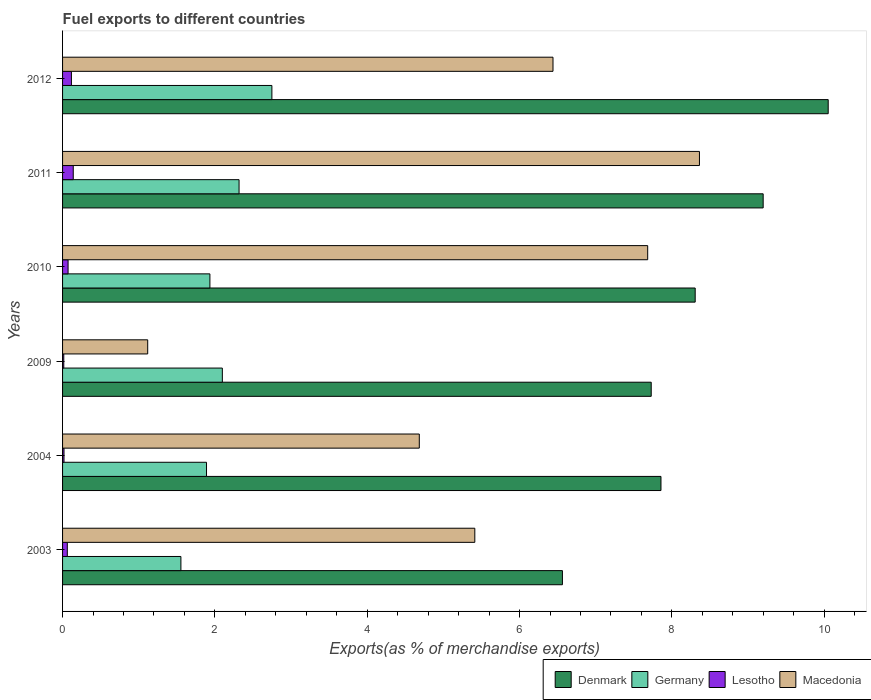Are the number of bars on each tick of the Y-axis equal?
Keep it short and to the point. Yes. How many bars are there on the 5th tick from the bottom?
Your answer should be compact. 4. What is the label of the 4th group of bars from the top?
Make the answer very short. 2009. In how many cases, is the number of bars for a given year not equal to the number of legend labels?
Provide a short and direct response. 0. What is the percentage of exports to different countries in Lesotho in 2009?
Your answer should be very brief. 0.02. Across all years, what is the maximum percentage of exports to different countries in Germany?
Your response must be concise. 2.75. Across all years, what is the minimum percentage of exports to different countries in Germany?
Your answer should be compact. 1.55. In which year was the percentage of exports to different countries in Denmark minimum?
Keep it short and to the point. 2003. What is the total percentage of exports to different countries in Denmark in the graph?
Provide a short and direct response. 49.7. What is the difference between the percentage of exports to different countries in Germany in 2003 and that in 2011?
Ensure brevity in your answer.  -0.76. What is the difference between the percentage of exports to different countries in Lesotho in 2009 and the percentage of exports to different countries in Denmark in 2012?
Offer a very short reply. -10.04. What is the average percentage of exports to different countries in Macedonia per year?
Offer a terse response. 5.62. In the year 2011, what is the difference between the percentage of exports to different countries in Denmark and percentage of exports to different countries in Germany?
Provide a succinct answer. 6.88. In how many years, is the percentage of exports to different countries in Macedonia greater than 7.6 %?
Provide a succinct answer. 2. What is the ratio of the percentage of exports to different countries in Germany in 2010 to that in 2012?
Make the answer very short. 0.7. Is the difference between the percentage of exports to different countries in Denmark in 2003 and 2004 greater than the difference between the percentage of exports to different countries in Germany in 2003 and 2004?
Make the answer very short. No. What is the difference between the highest and the second highest percentage of exports to different countries in Germany?
Ensure brevity in your answer.  0.43. What is the difference between the highest and the lowest percentage of exports to different countries in Lesotho?
Provide a short and direct response. 0.12. In how many years, is the percentage of exports to different countries in Germany greater than the average percentage of exports to different countries in Germany taken over all years?
Make the answer very short. 3. Is it the case that in every year, the sum of the percentage of exports to different countries in Denmark and percentage of exports to different countries in Lesotho is greater than the sum of percentage of exports to different countries in Macedonia and percentage of exports to different countries in Germany?
Offer a very short reply. Yes. What does the 2nd bar from the top in 2009 represents?
Give a very brief answer. Lesotho. What does the 4th bar from the bottom in 2010 represents?
Your answer should be very brief. Macedonia. How many bars are there?
Your answer should be compact. 24. Are all the bars in the graph horizontal?
Keep it short and to the point. Yes. How many years are there in the graph?
Your answer should be very brief. 6. Are the values on the major ticks of X-axis written in scientific E-notation?
Ensure brevity in your answer.  No. Where does the legend appear in the graph?
Offer a terse response. Bottom right. How many legend labels are there?
Provide a short and direct response. 4. What is the title of the graph?
Offer a very short reply. Fuel exports to different countries. What is the label or title of the X-axis?
Ensure brevity in your answer.  Exports(as % of merchandise exports). What is the label or title of the Y-axis?
Offer a terse response. Years. What is the Exports(as % of merchandise exports) in Denmark in 2003?
Give a very brief answer. 6.56. What is the Exports(as % of merchandise exports) of Germany in 2003?
Your answer should be compact. 1.55. What is the Exports(as % of merchandise exports) of Lesotho in 2003?
Offer a terse response. 0.06. What is the Exports(as % of merchandise exports) in Macedonia in 2003?
Ensure brevity in your answer.  5.41. What is the Exports(as % of merchandise exports) of Denmark in 2004?
Make the answer very short. 7.86. What is the Exports(as % of merchandise exports) of Germany in 2004?
Your answer should be compact. 1.89. What is the Exports(as % of merchandise exports) in Lesotho in 2004?
Make the answer very short. 0.02. What is the Exports(as % of merchandise exports) of Macedonia in 2004?
Make the answer very short. 4.68. What is the Exports(as % of merchandise exports) in Denmark in 2009?
Your answer should be compact. 7.73. What is the Exports(as % of merchandise exports) in Germany in 2009?
Keep it short and to the point. 2.1. What is the Exports(as % of merchandise exports) of Lesotho in 2009?
Offer a very short reply. 0.02. What is the Exports(as % of merchandise exports) of Macedonia in 2009?
Your response must be concise. 1.12. What is the Exports(as % of merchandise exports) of Denmark in 2010?
Your response must be concise. 8.31. What is the Exports(as % of merchandise exports) in Germany in 2010?
Offer a terse response. 1.93. What is the Exports(as % of merchandise exports) of Lesotho in 2010?
Make the answer very short. 0.07. What is the Exports(as % of merchandise exports) in Macedonia in 2010?
Your response must be concise. 7.68. What is the Exports(as % of merchandise exports) of Denmark in 2011?
Ensure brevity in your answer.  9.2. What is the Exports(as % of merchandise exports) in Germany in 2011?
Offer a very short reply. 2.32. What is the Exports(as % of merchandise exports) of Lesotho in 2011?
Offer a very short reply. 0.14. What is the Exports(as % of merchandise exports) in Macedonia in 2011?
Your response must be concise. 8.36. What is the Exports(as % of merchandise exports) of Denmark in 2012?
Keep it short and to the point. 10.05. What is the Exports(as % of merchandise exports) of Germany in 2012?
Ensure brevity in your answer.  2.75. What is the Exports(as % of merchandise exports) of Lesotho in 2012?
Give a very brief answer. 0.12. What is the Exports(as % of merchandise exports) of Macedonia in 2012?
Offer a very short reply. 6.44. Across all years, what is the maximum Exports(as % of merchandise exports) in Denmark?
Provide a succinct answer. 10.05. Across all years, what is the maximum Exports(as % of merchandise exports) of Germany?
Provide a succinct answer. 2.75. Across all years, what is the maximum Exports(as % of merchandise exports) in Lesotho?
Offer a terse response. 0.14. Across all years, what is the maximum Exports(as % of merchandise exports) in Macedonia?
Give a very brief answer. 8.36. Across all years, what is the minimum Exports(as % of merchandise exports) in Denmark?
Make the answer very short. 6.56. Across all years, what is the minimum Exports(as % of merchandise exports) in Germany?
Your response must be concise. 1.55. Across all years, what is the minimum Exports(as % of merchandise exports) in Lesotho?
Your response must be concise. 0.02. Across all years, what is the minimum Exports(as % of merchandise exports) of Macedonia?
Provide a short and direct response. 1.12. What is the total Exports(as % of merchandise exports) in Denmark in the graph?
Your response must be concise. 49.7. What is the total Exports(as % of merchandise exports) of Germany in the graph?
Your response must be concise. 12.54. What is the total Exports(as % of merchandise exports) of Lesotho in the graph?
Ensure brevity in your answer.  0.43. What is the total Exports(as % of merchandise exports) in Macedonia in the graph?
Offer a very short reply. 33.7. What is the difference between the Exports(as % of merchandise exports) of Denmark in 2003 and that in 2004?
Ensure brevity in your answer.  -1.29. What is the difference between the Exports(as % of merchandise exports) in Germany in 2003 and that in 2004?
Offer a very short reply. -0.34. What is the difference between the Exports(as % of merchandise exports) of Lesotho in 2003 and that in 2004?
Your answer should be very brief. 0.04. What is the difference between the Exports(as % of merchandise exports) in Macedonia in 2003 and that in 2004?
Offer a terse response. 0.73. What is the difference between the Exports(as % of merchandise exports) in Denmark in 2003 and that in 2009?
Provide a succinct answer. -1.17. What is the difference between the Exports(as % of merchandise exports) in Germany in 2003 and that in 2009?
Ensure brevity in your answer.  -0.54. What is the difference between the Exports(as % of merchandise exports) in Lesotho in 2003 and that in 2009?
Keep it short and to the point. 0.05. What is the difference between the Exports(as % of merchandise exports) in Macedonia in 2003 and that in 2009?
Offer a terse response. 4.29. What is the difference between the Exports(as % of merchandise exports) in Denmark in 2003 and that in 2010?
Your answer should be very brief. -1.74. What is the difference between the Exports(as % of merchandise exports) in Germany in 2003 and that in 2010?
Make the answer very short. -0.38. What is the difference between the Exports(as % of merchandise exports) of Lesotho in 2003 and that in 2010?
Provide a short and direct response. -0.01. What is the difference between the Exports(as % of merchandise exports) in Macedonia in 2003 and that in 2010?
Provide a succinct answer. -2.27. What is the difference between the Exports(as % of merchandise exports) in Denmark in 2003 and that in 2011?
Your response must be concise. -2.64. What is the difference between the Exports(as % of merchandise exports) of Germany in 2003 and that in 2011?
Keep it short and to the point. -0.76. What is the difference between the Exports(as % of merchandise exports) of Lesotho in 2003 and that in 2011?
Provide a succinct answer. -0.08. What is the difference between the Exports(as % of merchandise exports) of Macedonia in 2003 and that in 2011?
Make the answer very short. -2.95. What is the difference between the Exports(as % of merchandise exports) of Denmark in 2003 and that in 2012?
Offer a terse response. -3.49. What is the difference between the Exports(as % of merchandise exports) in Germany in 2003 and that in 2012?
Your response must be concise. -1.19. What is the difference between the Exports(as % of merchandise exports) of Lesotho in 2003 and that in 2012?
Provide a short and direct response. -0.05. What is the difference between the Exports(as % of merchandise exports) in Macedonia in 2003 and that in 2012?
Make the answer very short. -1.03. What is the difference between the Exports(as % of merchandise exports) in Denmark in 2004 and that in 2009?
Make the answer very short. 0.13. What is the difference between the Exports(as % of merchandise exports) in Germany in 2004 and that in 2009?
Your answer should be compact. -0.21. What is the difference between the Exports(as % of merchandise exports) in Lesotho in 2004 and that in 2009?
Your answer should be compact. 0. What is the difference between the Exports(as % of merchandise exports) in Macedonia in 2004 and that in 2009?
Keep it short and to the point. 3.57. What is the difference between the Exports(as % of merchandise exports) in Denmark in 2004 and that in 2010?
Keep it short and to the point. -0.45. What is the difference between the Exports(as % of merchandise exports) in Germany in 2004 and that in 2010?
Offer a terse response. -0.04. What is the difference between the Exports(as % of merchandise exports) in Lesotho in 2004 and that in 2010?
Your answer should be very brief. -0.05. What is the difference between the Exports(as % of merchandise exports) of Macedonia in 2004 and that in 2010?
Provide a short and direct response. -3. What is the difference between the Exports(as % of merchandise exports) of Denmark in 2004 and that in 2011?
Provide a succinct answer. -1.34. What is the difference between the Exports(as % of merchandise exports) in Germany in 2004 and that in 2011?
Provide a short and direct response. -0.43. What is the difference between the Exports(as % of merchandise exports) in Lesotho in 2004 and that in 2011?
Make the answer very short. -0.12. What is the difference between the Exports(as % of merchandise exports) of Macedonia in 2004 and that in 2011?
Make the answer very short. -3.68. What is the difference between the Exports(as % of merchandise exports) of Denmark in 2004 and that in 2012?
Offer a terse response. -2.2. What is the difference between the Exports(as % of merchandise exports) of Germany in 2004 and that in 2012?
Your answer should be very brief. -0.86. What is the difference between the Exports(as % of merchandise exports) in Lesotho in 2004 and that in 2012?
Your answer should be very brief. -0.1. What is the difference between the Exports(as % of merchandise exports) of Macedonia in 2004 and that in 2012?
Your answer should be compact. -1.76. What is the difference between the Exports(as % of merchandise exports) in Denmark in 2009 and that in 2010?
Offer a very short reply. -0.58. What is the difference between the Exports(as % of merchandise exports) of Germany in 2009 and that in 2010?
Keep it short and to the point. 0.16. What is the difference between the Exports(as % of merchandise exports) of Lesotho in 2009 and that in 2010?
Ensure brevity in your answer.  -0.06. What is the difference between the Exports(as % of merchandise exports) in Macedonia in 2009 and that in 2010?
Offer a very short reply. -6.56. What is the difference between the Exports(as % of merchandise exports) in Denmark in 2009 and that in 2011?
Your answer should be compact. -1.47. What is the difference between the Exports(as % of merchandise exports) of Germany in 2009 and that in 2011?
Offer a very short reply. -0.22. What is the difference between the Exports(as % of merchandise exports) in Lesotho in 2009 and that in 2011?
Your response must be concise. -0.12. What is the difference between the Exports(as % of merchandise exports) of Macedonia in 2009 and that in 2011?
Provide a short and direct response. -7.24. What is the difference between the Exports(as % of merchandise exports) in Denmark in 2009 and that in 2012?
Ensure brevity in your answer.  -2.32. What is the difference between the Exports(as % of merchandise exports) of Germany in 2009 and that in 2012?
Give a very brief answer. -0.65. What is the difference between the Exports(as % of merchandise exports) in Lesotho in 2009 and that in 2012?
Keep it short and to the point. -0.1. What is the difference between the Exports(as % of merchandise exports) of Macedonia in 2009 and that in 2012?
Ensure brevity in your answer.  -5.32. What is the difference between the Exports(as % of merchandise exports) in Denmark in 2010 and that in 2011?
Keep it short and to the point. -0.89. What is the difference between the Exports(as % of merchandise exports) in Germany in 2010 and that in 2011?
Provide a short and direct response. -0.38. What is the difference between the Exports(as % of merchandise exports) in Lesotho in 2010 and that in 2011?
Ensure brevity in your answer.  -0.07. What is the difference between the Exports(as % of merchandise exports) of Macedonia in 2010 and that in 2011?
Make the answer very short. -0.68. What is the difference between the Exports(as % of merchandise exports) in Denmark in 2010 and that in 2012?
Offer a very short reply. -1.75. What is the difference between the Exports(as % of merchandise exports) in Germany in 2010 and that in 2012?
Your response must be concise. -0.81. What is the difference between the Exports(as % of merchandise exports) of Lesotho in 2010 and that in 2012?
Your answer should be very brief. -0.04. What is the difference between the Exports(as % of merchandise exports) of Macedonia in 2010 and that in 2012?
Provide a succinct answer. 1.24. What is the difference between the Exports(as % of merchandise exports) in Denmark in 2011 and that in 2012?
Offer a terse response. -0.85. What is the difference between the Exports(as % of merchandise exports) of Germany in 2011 and that in 2012?
Keep it short and to the point. -0.43. What is the difference between the Exports(as % of merchandise exports) of Lesotho in 2011 and that in 2012?
Ensure brevity in your answer.  0.02. What is the difference between the Exports(as % of merchandise exports) of Macedonia in 2011 and that in 2012?
Keep it short and to the point. 1.92. What is the difference between the Exports(as % of merchandise exports) in Denmark in 2003 and the Exports(as % of merchandise exports) in Germany in 2004?
Provide a short and direct response. 4.67. What is the difference between the Exports(as % of merchandise exports) in Denmark in 2003 and the Exports(as % of merchandise exports) in Lesotho in 2004?
Give a very brief answer. 6.54. What is the difference between the Exports(as % of merchandise exports) in Denmark in 2003 and the Exports(as % of merchandise exports) in Macedonia in 2004?
Provide a short and direct response. 1.88. What is the difference between the Exports(as % of merchandise exports) of Germany in 2003 and the Exports(as % of merchandise exports) of Lesotho in 2004?
Keep it short and to the point. 1.53. What is the difference between the Exports(as % of merchandise exports) in Germany in 2003 and the Exports(as % of merchandise exports) in Macedonia in 2004?
Your response must be concise. -3.13. What is the difference between the Exports(as % of merchandise exports) in Lesotho in 2003 and the Exports(as % of merchandise exports) in Macedonia in 2004?
Keep it short and to the point. -4.62. What is the difference between the Exports(as % of merchandise exports) of Denmark in 2003 and the Exports(as % of merchandise exports) of Germany in 2009?
Your answer should be very brief. 4.46. What is the difference between the Exports(as % of merchandise exports) in Denmark in 2003 and the Exports(as % of merchandise exports) in Lesotho in 2009?
Your answer should be compact. 6.55. What is the difference between the Exports(as % of merchandise exports) in Denmark in 2003 and the Exports(as % of merchandise exports) in Macedonia in 2009?
Make the answer very short. 5.44. What is the difference between the Exports(as % of merchandise exports) in Germany in 2003 and the Exports(as % of merchandise exports) in Lesotho in 2009?
Offer a very short reply. 1.54. What is the difference between the Exports(as % of merchandise exports) of Germany in 2003 and the Exports(as % of merchandise exports) of Macedonia in 2009?
Your answer should be very brief. 0.44. What is the difference between the Exports(as % of merchandise exports) in Lesotho in 2003 and the Exports(as % of merchandise exports) in Macedonia in 2009?
Your response must be concise. -1.06. What is the difference between the Exports(as % of merchandise exports) in Denmark in 2003 and the Exports(as % of merchandise exports) in Germany in 2010?
Your response must be concise. 4.63. What is the difference between the Exports(as % of merchandise exports) of Denmark in 2003 and the Exports(as % of merchandise exports) of Lesotho in 2010?
Your answer should be very brief. 6.49. What is the difference between the Exports(as % of merchandise exports) of Denmark in 2003 and the Exports(as % of merchandise exports) of Macedonia in 2010?
Your answer should be compact. -1.12. What is the difference between the Exports(as % of merchandise exports) in Germany in 2003 and the Exports(as % of merchandise exports) in Lesotho in 2010?
Ensure brevity in your answer.  1.48. What is the difference between the Exports(as % of merchandise exports) in Germany in 2003 and the Exports(as % of merchandise exports) in Macedonia in 2010?
Your response must be concise. -6.13. What is the difference between the Exports(as % of merchandise exports) of Lesotho in 2003 and the Exports(as % of merchandise exports) of Macedonia in 2010?
Provide a short and direct response. -7.62. What is the difference between the Exports(as % of merchandise exports) in Denmark in 2003 and the Exports(as % of merchandise exports) in Germany in 2011?
Offer a very short reply. 4.25. What is the difference between the Exports(as % of merchandise exports) of Denmark in 2003 and the Exports(as % of merchandise exports) of Lesotho in 2011?
Your answer should be very brief. 6.42. What is the difference between the Exports(as % of merchandise exports) in Denmark in 2003 and the Exports(as % of merchandise exports) in Macedonia in 2011?
Ensure brevity in your answer.  -1.8. What is the difference between the Exports(as % of merchandise exports) in Germany in 2003 and the Exports(as % of merchandise exports) in Lesotho in 2011?
Offer a very short reply. 1.41. What is the difference between the Exports(as % of merchandise exports) of Germany in 2003 and the Exports(as % of merchandise exports) of Macedonia in 2011?
Your answer should be very brief. -6.81. What is the difference between the Exports(as % of merchandise exports) in Lesotho in 2003 and the Exports(as % of merchandise exports) in Macedonia in 2011?
Make the answer very short. -8.3. What is the difference between the Exports(as % of merchandise exports) of Denmark in 2003 and the Exports(as % of merchandise exports) of Germany in 2012?
Your response must be concise. 3.81. What is the difference between the Exports(as % of merchandise exports) of Denmark in 2003 and the Exports(as % of merchandise exports) of Lesotho in 2012?
Your answer should be very brief. 6.45. What is the difference between the Exports(as % of merchandise exports) of Denmark in 2003 and the Exports(as % of merchandise exports) of Macedonia in 2012?
Your answer should be very brief. 0.12. What is the difference between the Exports(as % of merchandise exports) in Germany in 2003 and the Exports(as % of merchandise exports) in Lesotho in 2012?
Offer a very short reply. 1.44. What is the difference between the Exports(as % of merchandise exports) in Germany in 2003 and the Exports(as % of merchandise exports) in Macedonia in 2012?
Provide a succinct answer. -4.89. What is the difference between the Exports(as % of merchandise exports) in Lesotho in 2003 and the Exports(as % of merchandise exports) in Macedonia in 2012?
Give a very brief answer. -6.38. What is the difference between the Exports(as % of merchandise exports) of Denmark in 2004 and the Exports(as % of merchandise exports) of Germany in 2009?
Keep it short and to the point. 5.76. What is the difference between the Exports(as % of merchandise exports) of Denmark in 2004 and the Exports(as % of merchandise exports) of Lesotho in 2009?
Give a very brief answer. 7.84. What is the difference between the Exports(as % of merchandise exports) of Denmark in 2004 and the Exports(as % of merchandise exports) of Macedonia in 2009?
Your answer should be very brief. 6.74. What is the difference between the Exports(as % of merchandise exports) in Germany in 2004 and the Exports(as % of merchandise exports) in Lesotho in 2009?
Offer a very short reply. 1.87. What is the difference between the Exports(as % of merchandise exports) of Germany in 2004 and the Exports(as % of merchandise exports) of Macedonia in 2009?
Your answer should be compact. 0.77. What is the difference between the Exports(as % of merchandise exports) in Lesotho in 2004 and the Exports(as % of merchandise exports) in Macedonia in 2009?
Offer a very short reply. -1.1. What is the difference between the Exports(as % of merchandise exports) in Denmark in 2004 and the Exports(as % of merchandise exports) in Germany in 2010?
Provide a succinct answer. 5.92. What is the difference between the Exports(as % of merchandise exports) of Denmark in 2004 and the Exports(as % of merchandise exports) of Lesotho in 2010?
Your answer should be compact. 7.78. What is the difference between the Exports(as % of merchandise exports) of Denmark in 2004 and the Exports(as % of merchandise exports) of Macedonia in 2010?
Ensure brevity in your answer.  0.17. What is the difference between the Exports(as % of merchandise exports) in Germany in 2004 and the Exports(as % of merchandise exports) in Lesotho in 2010?
Offer a terse response. 1.82. What is the difference between the Exports(as % of merchandise exports) of Germany in 2004 and the Exports(as % of merchandise exports) of Macedonia in 2010?
Your answer should be very brief. -5.79. What is the difference between the Exports(as % of merchandise exports) in Lesotho in 2004 and the Exports(as % of merchandise exports) in Macedonia in 2010?
Your answer should be very brief. -7.66. What is the difference between the Exports(as % of merchandise exports) in Denmark in 2004 and the Exports(as % of merchandise exports) in Germany in 2011?
Make the answer very short. 5.54. What is the difference between the Exports(as % of merchandise exports) of Denmark in 2004 and the Exports(as % of merchandise exports) of Lesotho in 2011?
Offer a very short reply. 7.72. What is the difference between the Exports(as % of merchandise exports) in Denmark in 2004 and the Exports(as % of merchandise exports) in Macedonia in 2011?
Keep it short and to the point. -0.51. What is the difference between the Exports(as % of merchandise exports) in Germany in 2004 and the Exports(as % of merchandise exports) in Lesotho in 2011?
Give a very brief answer. 1.75. What is the difference between the Exports(as % of merchandise exports) of Germany in 2004 and the Exports(as % of merchandise exports) of Macedonia in 2011?
Make the answer very short. -6.47. What is the difference between the Exports(as % of merchandise exports) in Lesotho in 2004 and the Exports(as % of merchandise exports) in Macedonia in 2011?
Ensure brevity in your answer.  -8.34. What is the difference between the Exports(as % of merchandise exports) in Denmark in 2004 and the Exports(as % of merchandise exports) in Germany in 2012?
Your response must be concise. 5.11. What is the difference between the Exports(as % of merchandise exports) in Denmark in 2004 and the Exports(as % of merchandise exports) in Lesotho in 2012?
Provide a succinct answer. 7.74. What is the difference between the Exports(as % of merchandise exports) of Denmark in 2004 and the Exports(as % of merchandise exports) of Macedonia in 2012?
Make the answer very short. 1.42. What is the difference between the Exports(as % of merchandise exports) of Germany in 2004 and the Exports(as % of merchandise exports) of Lesotho in 2012?
Keep it short and to the point. 1.77. What is the difference between the Exports(as % of merchandise exports) in Germany in 2004 and the Exports(as % of merchandise exports) in Macedonia in 2012?
Provide a short and direct response. -4.55. What is the difference between the Exports(as % of merchandise exports) of Lesotho in 2004 and the Exports(as % of merchandise exports) of Macedonia in 2012?
Ensure brevity in your answer.  -6.42. What is the difference between the Exports(as % of merchandise exports) in Denmark in 2009 and the Exports(as % of merchandise exports) in Germany in 2010?
Offer a terse response. 5.79. What is the difference between the Exports(as % of merchandise exports) in Denmark in 2009 and the Exports(as % of merchandise exports) in Lesotho in 2010?
Your response must be concise. 7.66. What is the difference between the Exports(as % of merchandise exports) of Denmark in 2009 and the Exports(as % of merchandise exports) of Macedonia in 2010?
Your answer should be compact. 0.05. What is the difference between the Exports(as % of merchandise exports) of Germany in 2009 and the Exports(as % of merchandise exports) of Lesotho in 2010?
Your response must be concise. 2.03. What is the difference between the Exports(as % of merchandise exports) of Germany in 2009 and the Exports(as % of merchandise exports) of Macedonia in 2010?
Offer a very short reply. -5.58. What is the difference between the Exports(as % of merchandise exports) of Lesotho in 2009 and the Exports(as % of merchandise exports) of Macedonia in 2010?
Your answer should be compact. -7.67. What is the difference between the Exports(as % of merchandise exports) in Denmark in 2009 and the Exports(as % of merchandise exports) in Germany in 2011?
Your answer should be compact. 5.41. What is the difference between the Exports(as % of merchandise exports) of Denmark in 2009 and the Exports(as % of merchandise exports) of Lesotho in 2011?
Your answer should be compact. 7.59. What is the difference between the Exports(as % of merchandise exports) in Denmark in 2009 and the Exports(as % of merchandise exports) in Macedonia in 2011?
Your answer should be very brief. -0.63. What is the difference between the Exports(as % of merchandise exports) of Germany in 2009 and the Exports(as % of merchandise exports) of Lesotho in 2011?
Keep it short and to the point. 1.96. What is the difference between the Exports(as % of merchandise exports) in Germany in 2009 and the Exports(as % of merchandise exports) in Macedonia in 2011?
Make the answer very short. -6.26. What is the difference between the Exports(as % of merchandise exports) in Lesotho in 2009 and the Exports(as % of merchandise exports) in Macedonia in 2011?
Offer a terse response. -8.35. What is the difference between the Exports(as % of merchandise exports) of Denmark in 2009 and the Exports(as % of merchandise exports) of Germany in 2012?
Your answer should be very brief. 4.98. What is the difference between the Exports(as % of merchandise exports) in Denmark in 2009 and the Exports(as % of merchandise exports) in Lesotho in 2012?
Provide a short and direct response. 7.61. What is the difference between the Exports(as % of merchandise exports) in Denmark in 2009 and the Exports(as % of merchandise exports) in Macedonia in 2012?
Your answer should be very brief. 1.29. What is the difference between the Exports(as % of merchandise exports) of Germany in 2009 and the Exports(as % of merchandise exports) of Lesotho in 2012?
Offer a very short reply. 1.98. What is the difference between the Exports(as % of merchandise exports) of Germany in 2009 and the Exports(as % of merchandise exports) of Macedonia in 2012?
Offer a terse response. -4.34. What is the difference between the Exports(as % of merchandise exports) in Lesotho in 2009 and the Exports(as % of merchandise exports) in Macedonia in 2012?
Offer a terse response. -6.42. What is the difference between the Exports(as % of merchandise exports) of Denmark in 2010 and the Exports(as % of merchandise exports) of Germany in 2011?
Your answer should be very brief. 5.99. What is the difference between the Exports(as % of merchandise exports) of Denmark in 2010 and the Exports(as % of merchandise exports) of Lesotho in 2011?
Offer a very short reply. 8.17. What is the difference between the Exports(as % of merchandise exports) of Denmark in 2010 and the Exports(as % of merchandise exports) of Macedonia in 2011?
Your answer should be very brief. -0.06. What is the difference between the Exports(as % of merchandise exports) in Germany in 2010 and the Exports(as % of merchandise exports) in Lesotho in 2011?
Your answer should be very brief. 1.79. What is the difference between the Exports(as % of merchandise exports) of Germany in 2010 and the Exports(as % of merchandise exports) of Macedonia in 2011?
Your response must be concise. -6.43. What is the difference between the Exports(as % of merchandise exports) of Lesotho in 2010 and the Exports(as % of merchandise exports) of Macedonia in 2011?
Offer a very short reply. -8.29. What is the difference between the Exports(as % of merchandise exports) in Denmark in 2010 and the Exports(as % of merchandise exports) in Germany in 2012?
Provide a short and direct response. 5.56. What is the difference between the Exports(as % of merchandise exports) of Denmark in 2010 and the Exports(as % of merchandise exports) of Lesotho in 2012?
Offer a terse response. 8.19. What is the difference between the Exports(as % of merchandise exports) of Denmark in 2010 and the Exports(as % of merchandise exports) of Macedonia in 2012?
Keep it short and to the point. 1.87. What is the difference between the Exports(as % of merchandise exports) of Germany in 2010 and the Exports(as % of merchandise exports) of Lesotho in 2012?
Your response must be concise. 1.82. What is the difference between the Exports(as % of merchandise exports) in Germany in 2010 and the Exports(as % of merchandise exports) in Macedonia in 2012?
Your response must be concise. -4.5. What is the difference between the Exports(as % of merchandise exports) of Lesotho in 2010 and the Exports(as % of merchandise exports) of Macedonia in 2012?
Ensure brevity in your answer.  -6.37. What is the difference between the Exports(as % of merchandise exports) of Denmark in 2011 and the Exports(as % of merchandise exports) of Germany in 2012?
Your answer should be compact. 6.45. What is the difference between the Exports(as % of merchandise exports) in Denmark in 2011 and the Exports(as % of merchandise exports) in Lesotho in 2012?
Your response must be concise. 9.08. What is the difference between the Exports(as % of merchandise exports) of Denmark in 2011 and the Exports(as % of merchandise exports) of Macedonia in 2012?
Keep it short and to the point. 2.76. What is the difference between the Exports(as % of merchandise exports) in Germany in 2011 and the Exports(as % of merchandise exports) in Lesotho in 2012?
Ensure brevity in your answer.  2.2. What is the difference between the Exports(as % of merchandise exports) of Germany in 2011 and the Exports(as % of merchandise exports) of Macedonia in 2012?
Provide a short and direct response. -4.12. What is the difference between the Exports(as % of merchandise exports) in Lesotho in 2011 and the Exports(as % of merchandise exports) in Macedonia in 2012?
Make the answer very short. -6.3. What is the average Exports(as % of merchandise exports) in Denmark per year?
Offer a very short reply. 8.28. What is the average Exports(as % of merchandise exports) in Germany per year?
Offer a very short reply. 2.09. What is the average Exports(as % of merchandise exports) in Lesotho per year?
Offer a terse response. 0.07. What is the average Exports(as % of merchandise exports) of Macedonia per year?
Make the answer very short. 5.62. In the year 2003, what is the difference between the Exports(as % of merchandise exports) in Denmark and Exports(as % of merchandise exports) in Germany?
Ensure brevity in your answer.  5.01. In the year 2003, what is the difference between the Exports(as % of merchandise exports) in Denmark and Exports(as % of merchandise exports) in Lesotho?
Your answer should be compact. 6.5. In the year 2003, what is the difference between the Exports(as % of merchandise exports) of Denmark and Exports(as % of merchandise exports) of Macedonia?
Make the answer very short. 1.15. In the year 2003, what is the difference between the Exports(as % of merchandise exports) of Germany and Exports(as % of merchandise exports) of Lesotho?
Offer a terse response. 1.49. In the year 2003, what is the difference between the Exports(as % of merchandise exports) of Germany and Exports(as % of merchandise exports) of Macedonia?
Ensure brevity in your answer.  -3.86. In the year 2003, what is the difference between the Exports(as % of merchandise exports) in Lesotho and Exports(as % of merchandise exports) in Macedonia?
Give a very brief answer. -5.35. In the year 2004, what is the difference between the Exports(as % of merchandise exports) of Denmark and Exports(as % of merchandise exports) of Germany?
Your response must be concise. 5.97. In the year 2004, what is the difference between the Exports(as % of merchandise exports) in Denmark and Exports(as % of merchandise exports) in Lesotho?
Your answer should be compact. 7.84. In the year 2004, what is the difference between the Exports(as % of merchandise exports) in Denmark and Exports(as % of merchandise exports) in Macedonia?
Provide a succinct answer. 3.17. In the year 2004, what is the difference between the Exports(as % of merchandise exports) of Germany and Exports(as % of merchandise exports) of Lesotho?
Offer a terse response. 1.87. In the year 2004, what is the difference between the Exports(as % of merchandise exports) in Germany and Exports(as % of merchandise exports) in Macedonia?
Keep it short and to the point. -2.79. In the year 2004, what is the difference between the Exports(as % of merchandise exports) of Lesotho and Exports(as % of merchandise exports) of Macedonia?
Your answer should be compact. -4.66. In the year 2009, what is the difference between the Exports(as % of merchandise exports) of Denmark and Exports(as % of merchandise exports) of Germany?
Offer a very short reply. 5.63. In the year 2009, what is the difference between the Exports(as % of merchandise exports) of Denmark and Exports(as % of merchandise exports) of Lesotho?
Offer a terse response. 7.71. In the year 2009, what is the difference between the Exports(as % of merchandise exports) in Denmark and Exports(as % of merchandise exports) in Macedonia?
Provide a succinct answer. 6.61. In the year 2009, what is the difference between the Exports(as % of merchandise exports) of Germany and Exports(as % of merchandise exports) of Lesotho?
Your response must be concise. 2.08. In the year 2009, what is the difference between the Exports(as % of merchandise exports) in Germany and Exports(as % of merchandise exports) in Macedonia?
Provide a succinct answer. 0.98. In the year 2009, what is the difference between the Exports(as % of merchandise exports) in Lesotho and Exports(as % of merchandise exports) in Macedonia?
Ensure brevity in your answer.  -1.1. In the year 2010, what is the difference between the Exports(as % of merchandise exports) of Denmark and Exports(as % of merchandise exports) of Germany?
Provide a succinct answer. 6.37. In the year 2010, what is the difference between the Exports(as % of merchandise exports) in Denmark and Exports(as % of merchandise exports) in Lesotho?
Keep it short and to the point. 8.23. In the year 2010, what is the difference between the Exports(as % of merchandise exports) of Denmark and Exports(as % of merchandise exports) of Macedonia?
Offer a terse response. 0.62. In the year 2010, what is the difference between the Exports(as % of merchandise exports) of Germany and Exports(as % of merchandise exports) of Lesotho?
Make the answer very short. 1.86. In the year 2010, what is the difference between the Exports(as % of merchandise exports) in Germany and Exports(as % of merchandise exports) in Macedonia?
Provide a short and direct response. -5.75. In the year 2010, what is the difference between the Exports(as % of merchandise exports) in Lesotho and Exports(as % of merchandise exports) in Macedonia?
Ensure brevity in your answer.  -7.61. In the year 2011, what is the difference between the Exports(as % of merchandise exports) in Denmark and Exports(as % of merchandise exports) in Germany?
Your answer should be very brief. 6.88. In the year 2011, what is the difference between the Exports(as % of merchandise exports) in Denmark and Exports(as % of merchandise exports) in Lesotho?
Offer a terse response. 9.06. In the year 2011, what is the difference between the Exports(as % of merchandise exports) in Denmark and Exports(as % of merchandise exports) in Macedonia?
Keep it short and to the point. 0.84. In the year 2011, what is the difference between the Exports(as % of merchandise exports) of Germany and Exports(as % of merchandise exports) of Lesotho?
Give a very brief answer. 2.18. In the year 2011, what is the difference between the Exports(as % of merchandise exports) in Germany and Exports(as % of merchandise exports) in Macedonia?
Offer a very short reply. -6.04. In the year 2011, what is the difference between the Exports(as % of merchandise exports) in Lesotho and Exports(as % of merchandise exports) in Macedonia?
Offer a very short reply. -8.22. In the year 2012, what is the difference between the Exports(as % of merchandise exports) in Denmark and Exports(as % of merchandise exports) in Germany?
Your response must be concise. 7.3. In the year 2012, what is the difference between the Exports(as % of merchandise exports) in Denmark and Exports(as % of merchandise exports) in Lesotho?
Your answer should be very brief. 9.94. In the year 2012, what is the difference between the Exports(as % of merchandise exports) in Denmark and Exports(as % of merchandise exports) in Macedonia?
Provide a succinct answer. 3.61. In the year 2012, what is the difference between the Exports(as % of merchandise exports) in Germany and Exports(as % of merchandise exports) in Lesotho?
Provide a succinct answer. 2.63. In the year 2012, what is the difference between the Exports(as % of merchandise exports) in Germany and Exports(as % of merchandise exports) in Macedonia?
Provide a succinct answer. -3.69. In the year 2012, what is the difference between the Exports(as % of merchandise exports) in Lesotho and Exports(as % of merchandise exports) in Macedonia?
Your response must be concise. -6.32. What is the ratio of the Exports(as % of merchandise exports) of Denmark in 2003 to that in 2004?
Offer a very short reply. 0.84. What is the ratio of the Exports(as % of merchandise exports) in Germany in 2003 to that in 2004?
Your answer should be compact. 0.82. What is the ratio of the Exports(as % of merchandise exports) in Lesotho in 2003 to that in 2004?
Provide a succinct answer. 3.3. What is the ratio of the Exports(as % of merchandise exports) in Macedonia in 2003 to that in 2004?
Offer a terse response. 1.16. What is the ratio of the Exports(as % of merchandise exports) of Denmark in 2003 to that in 2009?
Offer a terse response. 0.85. What is the ratio of the Exports(as % of merchandise exports) in Germany in 2003 to that in 2009?
Give a very brief answer. 0.74. What is the ratio of the Exports(as % of merchandise exports) of Lesotho in 2003 to that in 2009?
Offer a very short reply. 3.92. What is the ratio of the Exports(as % of merchandise exports) in Macedonia in 2003 to that in 2009?
Give a very brief answer. 4.84. What is the ratio of the Exports(as % of merchandise exports) of Denmark in 2003 to that in 2010?
Your answer should be very brief. 0.79. What is the ratio of the Exports(as % of merchandise exports) in Germany in 2003 to that in 2010?
Your answer should be very brief. 0.8. What is the ratio of the Exports(as % of merchandise exports) of Lesotho in 2003 to that in 2010?
Offer a terse response. 0.86. What is the ratio of the Exports(as % of merchandise exports) in Macedonia in 2003 to that in 2010?
Your answer should be compact. 0.7. What is the ratio of the Exports(as % of merchandise exports) in Denmark in 2003 to that in 2011?
Your answer should be compact. 0.71. What is the ratio of the Exports(as % of merchandise exports) of Germany in 2003 to that in 2011?
Keep it short and to the point. 0.67. What is the ratio of the Exports(as % of merchandise exports) in Lesotho in 2003 to that in 2011?
Your response must be concise. 0.44. What is the ratio of the Exports(as % of merchandise exports) in Macedonia in 2003 to that in 2011?
Your answer should be compact. 0.65. What is the ratio of the Exports(as % of merchandise exports) of Denmark in 2003 to that in 2012?
Your answer should be compact. 0.65. What is the ratio of the Exports(as % of merchandise exports) in Germany in 2003 to that in 2012?
Offer a very short reply. 0.57. What is the ratio of the Exports(as % of merchandise exports) of Lesotho in 2003 to that in 2012?
Your response must be concise. 0.54. What is the ratio of the Exports(as % of merchandise exports) in Macedonia in 2003 to that in 2012?
Make the answer very short. 0.84. What is the ratio of the Exports(as % of merchandise exports) in Denmark in 2004 to that in 2009?
Give a very brief answer. 1.02. What is the ratio of the Exports(as % of merchandise exports) in Germany in 2004 to that in 2009?
Provide a short and direct response. 0.9. What is the ratio of the Exports(as % of merchandise exports) of Lesotho in 2004 to that in 2009?
Your answer should be very brief. 1.19. What is the ratio of the Exports(as % of merchandise exports) in Macedonia in 2004 to that in 2009?
Ensure brevity in your answer.  4.19. What is the ratio of the Exports(as % of merchandise exports) of Denmark in 2004 to that in 2010?
Give a very brief answer. 0.95. What is the ratio of the Exports(as % of merchandise exports) in Lesotho in 2004 to that in 2010?
Provide a succinct answer. 0.26. What is the ratio of the Exports(as % of merchandise exports) in Macedonia in 2004 to that in 2010?
Your answer should be compact. 0.61. What is the ratio of the Exports(as % of merchandise exports) in Denmark in 2004 to that in 2011?
Offer a terse response. 0.85. What is the ratio of the Exports(as % of merchandise exports) in Germany in 2004 to that in 2011?
Your answer should be very brief. 0.82. What is the ratio of the Exports(as % of merchandise exports) of Lesotho in 2004 to that in 2011?
Your response must be concise. 0.13. What is the ratio of the Exports(as % of merchandise exports) in Macedonia in 2004 to that in 2011?
Your response must be concise. 0.56. What is the ratio of the Exports(as % of merchandise exports) of Denmark in 2004 to that in 2012?
Ensure brevity in your answer.  0.78. What is the ratio of the Exports(as % of merchandise exports) of Germany in 2004 to that in 2012?
Ensure brevity in your answer.  0.69. What is the ratio of the Exports(as % of merchandise exports) in Lesotho in 2004 to that in 2012?
Make the answer very short. 0.16. What is the ratio of the Exports(as % of merchandise exports) of Macedonia in 2004 to that in 2012?
Provide a succinct answer. 0.73. What is the ratio of the Exports(as % of merchandise exports) in Denmark in 2009 to that in 2010?
Provide a succinct answer. 0.93. What is the ratio of the Exports(as % of merchandise exports) in Germany in 2009 to that in 2010?
Ensure brevity in your answer.  1.08. What is the ratio of the Exports(as % of merchandise exports) of Lesotho in 2009 to that in 2010?
Ensure brevity in your answer.  0.22. What is the ratio of the Exports(as % of merchandise exports) in Macedonia in 2009 to that in 2010?
Offer a terse response. 0.15. What is the ratio of the Exports(as % of merchandise exports) in Denmark in 2009 to that in 2011?
Ensure brevity in your answer.  0.84. What is the ratio of the Exports(as % of merchandise exports) of Germany in 2009 to that in 2011?
Offer a terse response. 0.91. What is the ratio of the Exports(as % of merchandise exports) in Lesotho in 2009 to that in 2011?
Provide a short and direct response. 0.11. What is the ratio of the Exports(as % of merchandise exports) in Macedonia in 2009 to that in 2011?
Your response must be concise. 0.13. What is the ratio of the Exports(as % of merchandise exports) of Denmark in 2009 to that in 2012?
Your answer should be compact. 0.77. What is the ratio of the Exports(as % of merchandise exports) of Germany in 2009 to that in 2012?
Your response must be concise. 0.76. What is the ratio of the Exports(as % of merchandise exports) of Lesotho in 2009 to that in 2012?
Your answer should be very brief. 0.14. What is the ratio of the Exports(as % of merchandise exports) in Macedonia in 2009 to that in 2012?
Offer a very short reply. 0.17. What is the ratio of the Exports(as % of merchandise exports) of Denmark in 2010 to that in 2011?
Your answer should be compact. 0.9. What is the ratio of the Exports(as % of merchandise exports) in Germany in 2010 to that in 2011?
Offer a terse response. 0.83. What is the ratio of the Exports(as % of merchandise exports) of Lesotho in 2010 to that in 2011?
Provide a succinct answer. 0.52. What is the ratio of the Exports(as % of merchandise exports) of Macedonia in 2010 to that in 2011?
Ensure brevity in your answer.  0.92. What is the ratio of the Exports(as % of merchandise exports) in Denmark in 2010 to that in 2012?
Ensure brevity in your answer.  0.83. What is the ratio of the Exports(as % of merchandise exports) of Germany in 2010 to that in 2012?
Your answer should be compact. 0.7. What is the ratio of the Exports(as % of merchandise exports) of Lesotho in 2010 to that in 2012?
Your answer should be compact. 0.62. What is the ratio of the Exports(as % of merchandise exports) of Macedonia in 2010 to that in 2012?
Make the answer very short. 1.19. What is the ratio of the Exports(as % of merchandise exports) in Denmark in 2011 to that in 2012?
Ensure brevity in your answer.  0.92. What is the ratio of the Exports(as % of merchandise exports) in Germany in 2011 to that in 2012?
Your answer should be very brief. 0.84. What is the ratio of the Exports(as % of merchandise exports) in Lesotho in 2011 to that in 2012?
Offer a very short reply. 1.21. What is the ratio of the Exports(as % of merchandise exports) of Macedonia in 2011 to that in 2012?
Make the answer very short. 1.3. What is the difference between the highest and the second highest Exports(as % of merchandise exports) in Denmark?
Your answer should be very brief. 0.85. What is the difference between the highest and the second highest Exports(as % of merchandise exports) in Germany?
Provide a succinct answer. 0.43. What is the difference between the highest and the second highest Exports(as % of merchandise exports) of Lesotho?
Provide a succinct answer. 0.02. What is the difference between the highest and the second highest Exports(as % of merchandise exports) in Macedonia?
Provide a succinct answer. 0.68. What is the difference between the highest and the lowest Exports(as % of merchandise exports) of Denmark?
Give a very brief answer. 3.49. What is the difference between the highest and the lowest Exports(as % of merchandise exports) in Germany?
Keep it short and to the point. 1.19. What is the difference between the highest and the lowest Exports(as % of merchandise exports) of Lesotho?
Ensure brevity in your answer.  0.12. What is the difference between the highest and the lowest Exports(as % of merchandise exports) of Macedonia?
Your response must be concise. 7.24. 